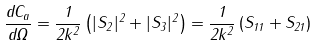<formula> <loc_0><loc_0><loc_500><loc_500>\frac { d C _ { a } } { d \Omega } = \frac { 1 } { 2 k ^ { 2 } } \left ( | S _ { 2 } | ^ { 2 } + | S _ { 3 } | ^ { 2 } \right ) = \frac { 1 } { 2 k ^ { 2 } } \left ( S _ { 1 1 } + S _ { 2 1 } \right )</formula> 